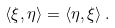<formula> <loc_0><loc_0><loc_500><loc_500>\langle \xi , \eta \rangle = \langle \eta , \xi \rangle \, .</formula> 